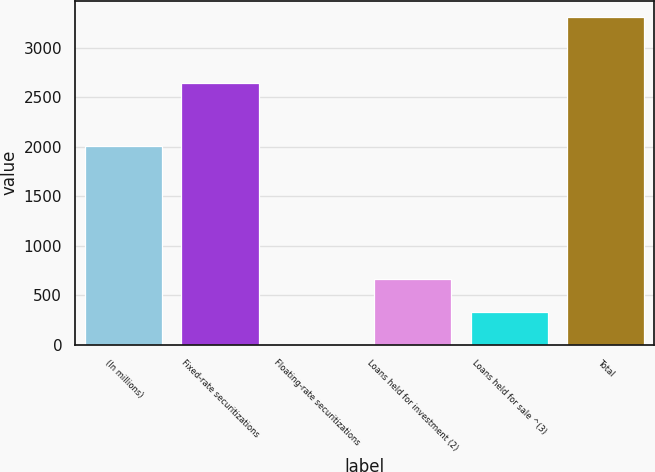Convert chart. <chart><loc_0><loc_0><loc_500><loc_500><bar_chart><fcel>(In millions)<fcel>Fixed-rate securitizations<fcel>Floating-rate securitizations<fcel>Loans held for investment (2)<fcel>Loans held for sale ^(3)<fcel>Total<nl><fcel>2007<fcel>2644.1<fcel>0.6<fcel>662.68<fcel>331.64<fcel>3311<nl></chart> 